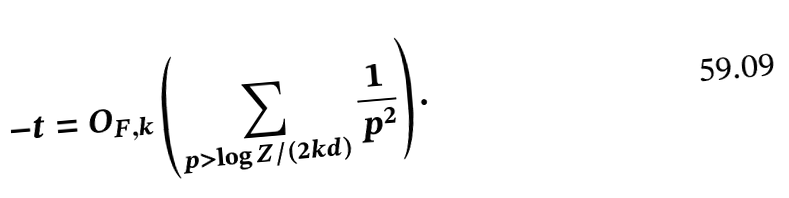Convert formula to latex. <formula><loc_0><loc_0><loc_500><loc_500>- t = O _ { F , k } \left ( \sum _ { p > \log Z / ( 2 k d ) } \frac { 1 } { p ^ { 2 } } \right ) .</formula> 